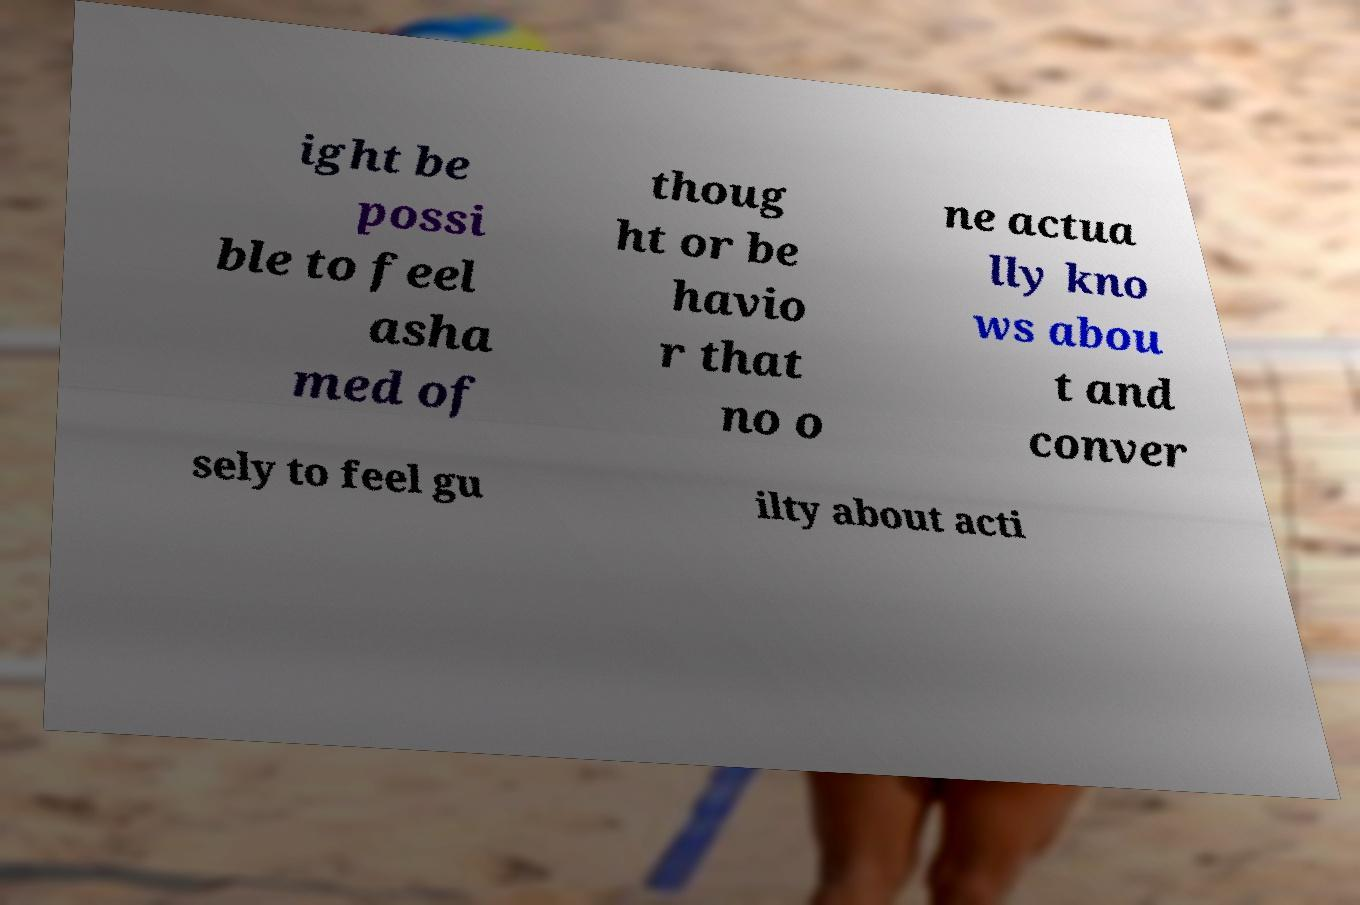Can you accurately transcribe the text from the provided image for me? ight be possi ble to feel asha med of thoug ht or be havio r that no o ne actua lly kno ws abou t and conver sely to feel gu ilty about acti 